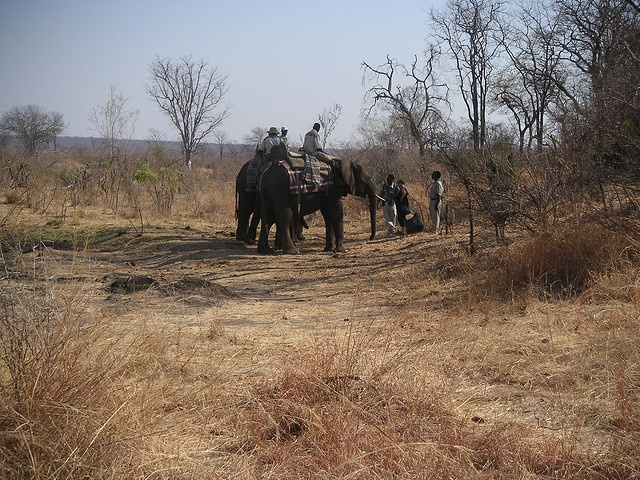Describe the objects in this image and their specific colors. I can see elephant in gray, black, and maroon tones, elephant in gray, black, and maroon tones, people in gray, black, darkgray, and lightgray tones, people in gray and black tones, and people in gray, black, and darkgray tones in this image. 